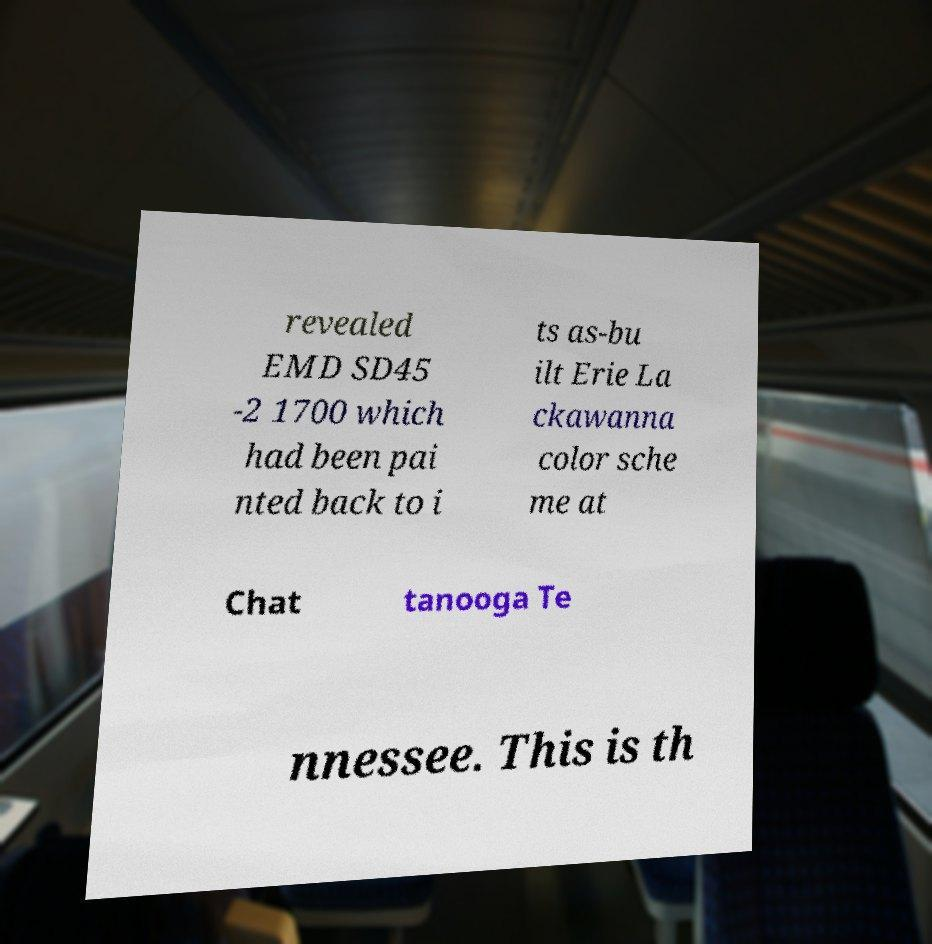There's text embedded in this image that I need extracted. Can you transcribe it verbatim? revealed EMD SD45 -2 1700 which had been pai nted back to i ts as-bu ilt Erie La ckawanna color sche me at Chat tanooga Te nnessee. This is th 